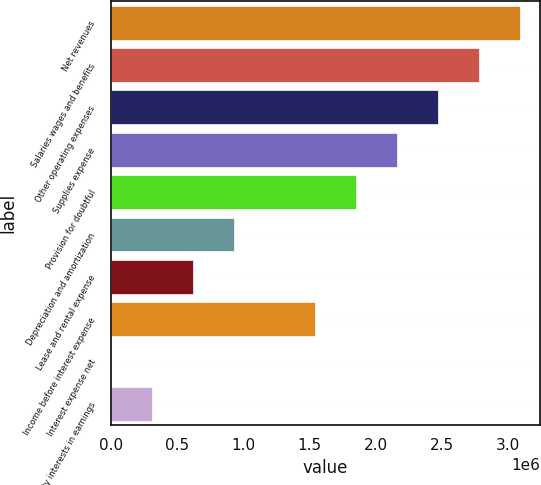Convert chart to OTSL. <chart><loc_0><loc_0><loc_500><loc_500><bar_chart><fcel>Net revenues<fcel>Salaries wages and benefits<fcel>Other operating expenses<fcel>Supplies expense<fcel>Provision for doubtful<fcel>Depreciation and amortization<fcel>Lease and rental expense<fcel>Income before interest expense<fcel>Interest expense net<fcel>Minority interests in earnings<nl><fcel>3.09052e+06<fcel>2.78163e+06<fcel>2.47274e+06<fcel>2.16385e+06<fcel>1.85496e+06<fcel>928291<fcel>619400<fcel>1.54607e+06<fcel>1619<fcel>310510<nl></chart> 